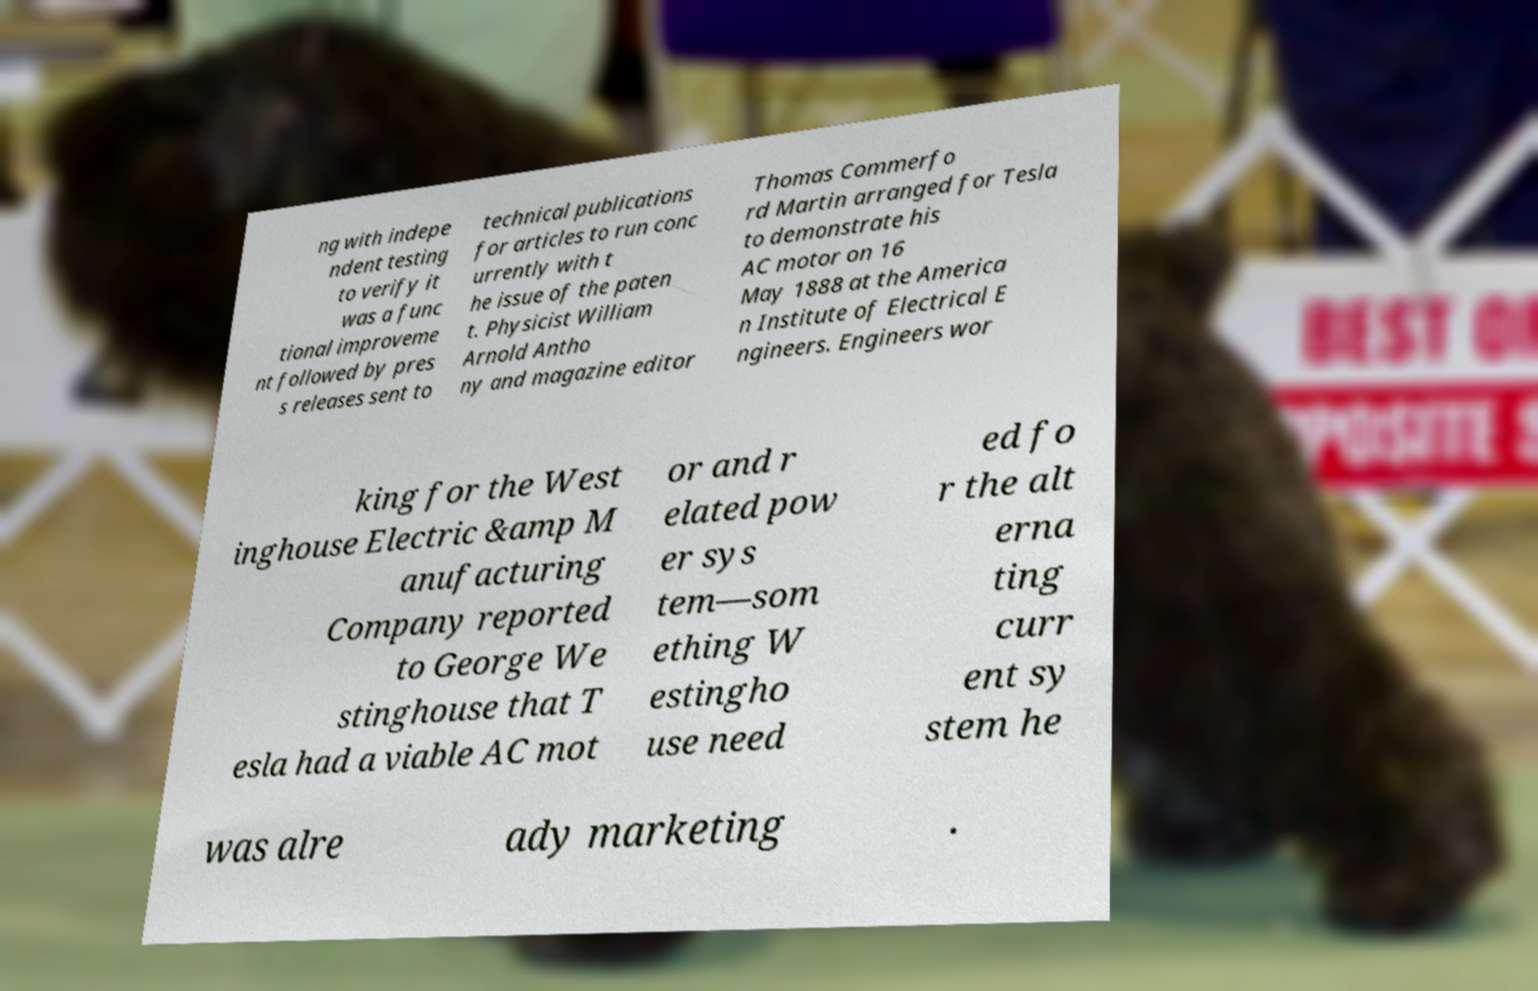What messages or text are displayed in this image? I need them in a readable, typed format. ng with indepe ndent testing to verify it was a func tional improveme nt followed by pres s releases sent to technical publications for articles to run conc urrently with t he issue of the paten t. Physicist William Arnold Antho ny and magazine editor Thomas Commerfo rd Martin arranged for Tesla to demonstrate his AC motor on 16 May 1888 at the America n Institute of Electrical E ngineers. Engineers wor king for the West inghouse Electric &amp M anufacturing Company reported to George We stinghouse that T esla had a viable AC mot or and r elated pow er sys tem—som ething W estingho use need ed fo r the alt erna ting curr ent sy stem he was alre ady marketing . 